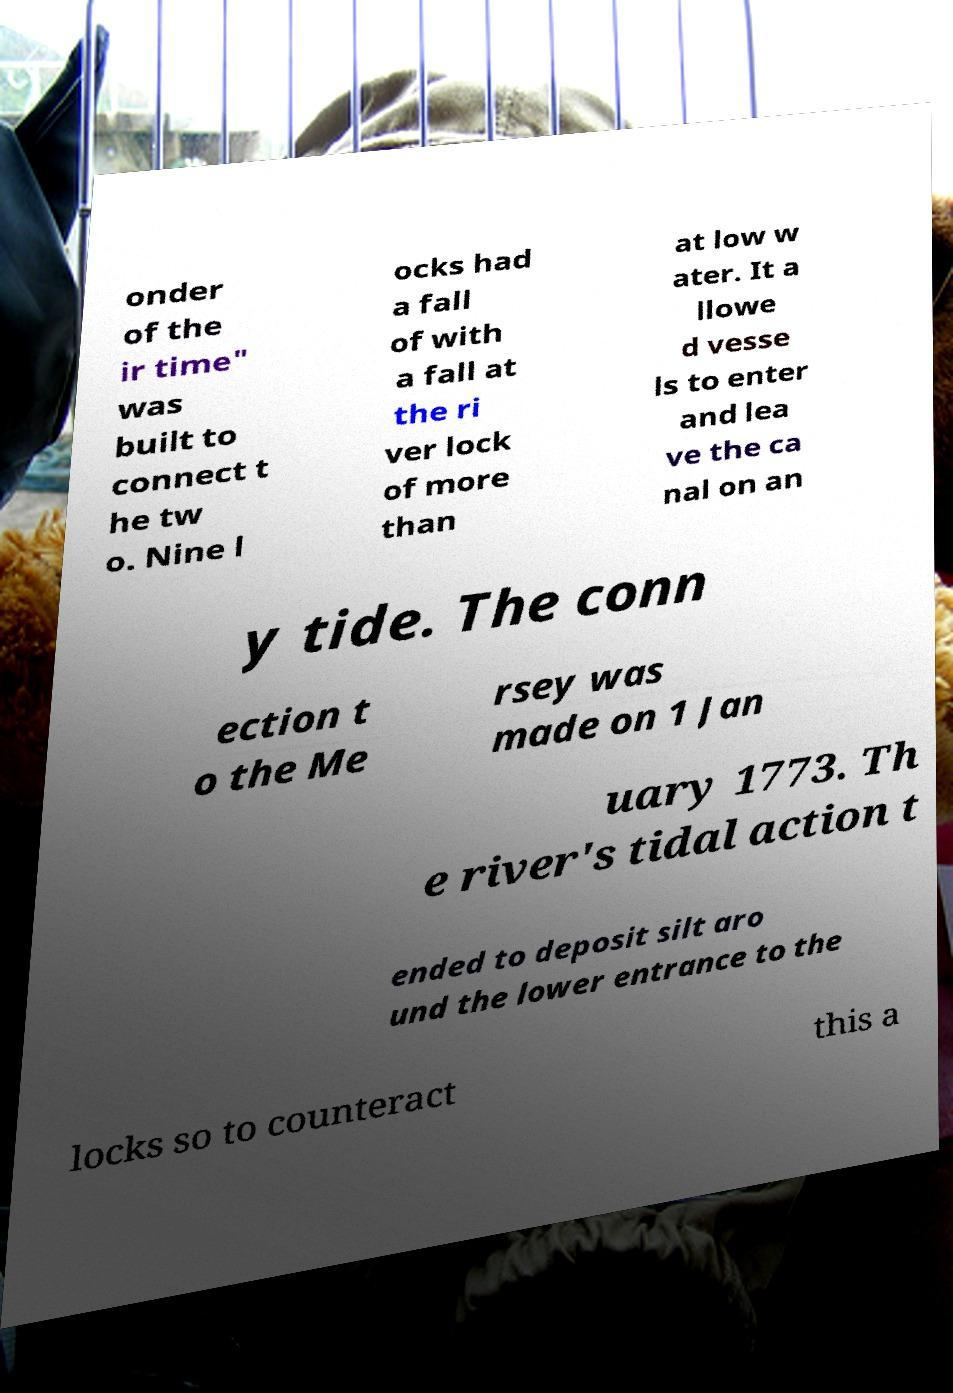Could you extract and type out the text from this image? onder of the ir time" was built to connect t he tw o. Nine l ocks had a fall of with a fall at the ri ver lock of more than at low w ater. It a llowe d vesse ls to enter and lea ve the ca nal on an y tide. The conn ection t o the Me rsey was made on 1 Jan uary 1773. Th e river's tidal action t ended to deposit silt aro und the lower entrance to the locks so to counteract this a 